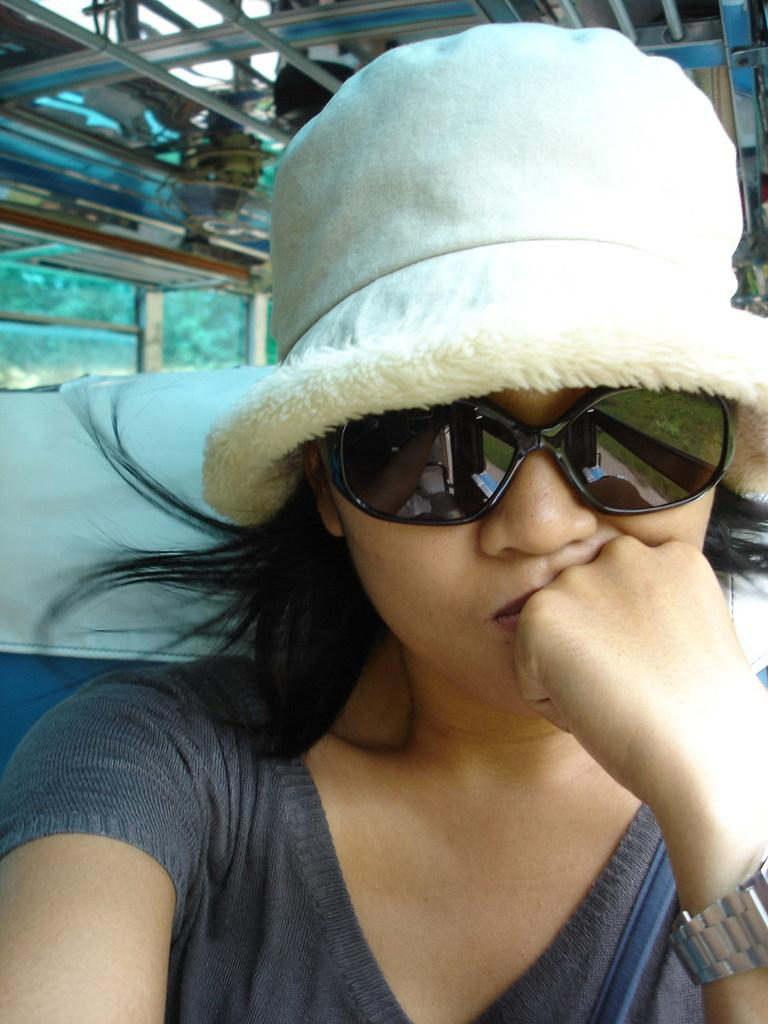Who is present in the image? There are women in the image. What are the women wearing on their faces? The women are wearing spectacles. What are the women wearing on their heads? The women are wearing caps. What can be seen in the background of the image? There are iron rods and a tree in the background of the image. What type of heat can be felt coming from the edge of the image? There is no heat or edge present in the image; it is a two-dimensional representation. 